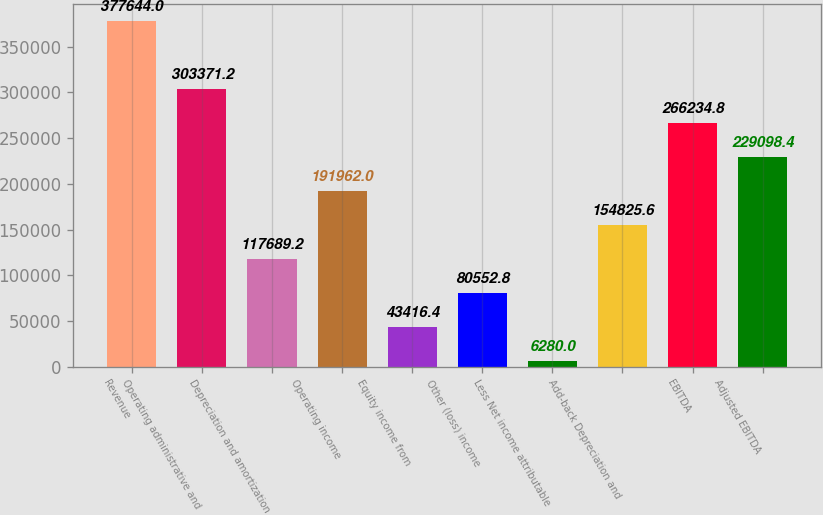Convert chart. <chart><loc_0><loc_0><loc_500><loc_500><bar_chart><fcel>Revenue<fcel>Operating administrative and<fcel>Depreciation and amortization<fcel>Operating income<fcel>Equity income from<fcel>Other (loss) income<fcel>Less Net income attributable<fcel>Add-back Depreciation and<fcel>EBITDA<fcel>Adjusted EBITDA<nl><fcel>377644<fcel>303371<fcel>117689<fcel>191962<fcel>43416.4<fcel>80552.8<fcel>6280<fcel>154826<fcel>266235<fcel>229098<nl></chart> 